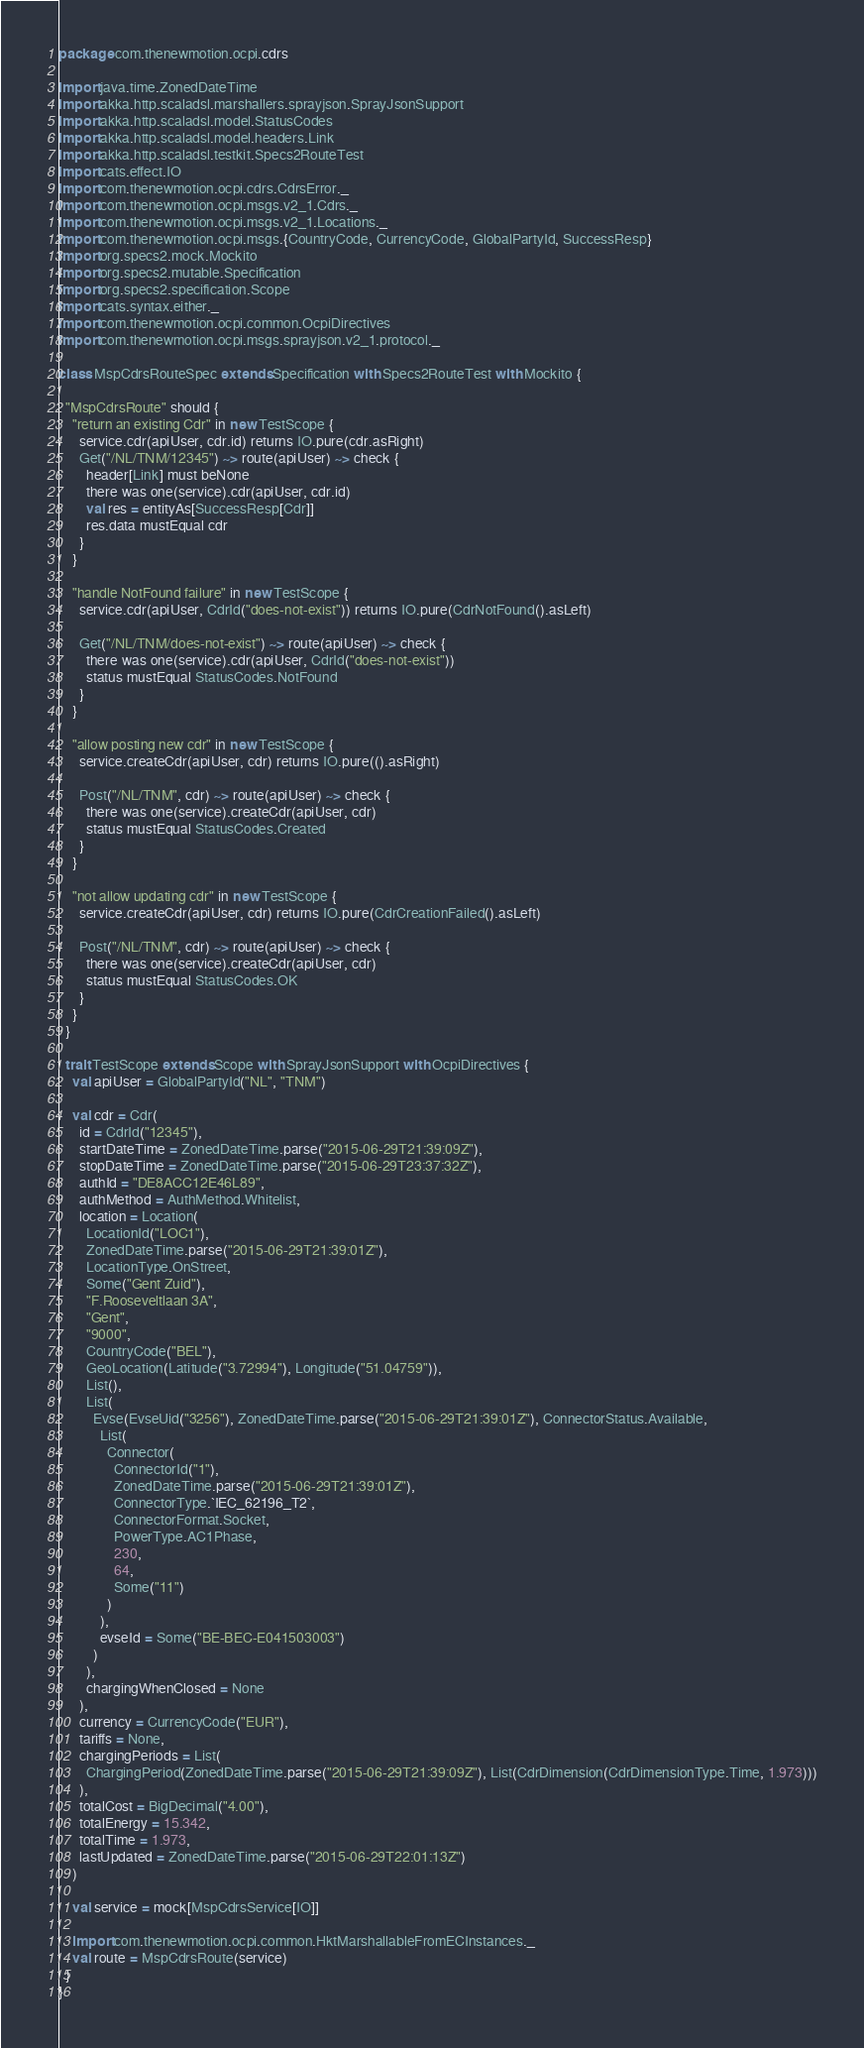<code> <loc_0><loc_0><loc_500><loc_500><_Scala_>package com.thenewmotion.ocpi.cdrs

import java.time.ZonedDateTime
import akka.http.scaladsl.marshallers.sprayjson.SprayJsonSupport
import akka.http.scaladsl.model.StatusCodes
import akka.http.scaladsl.model.headers.Link
import akka.http.scaladsl.testkit.Specs2RouteTest
import cats.effect.IO
import com.thenewmotion.ocpi.cdrs.CdrsError._
import com.thenewmotion.ocpi.msgs.v2_1.Cdrs._
import com.thenewmotion.ocpi.msgs.v2_1.Locations._
import com.thenewmotion.ocpi.msgs.{CountryCode, CurrencyCode, GlobalPartyId, SuccessResp}
import org.specs2.mock.Mockito
import org.specs2.mutable.Specification
import org.specs2.specification.Scope
import cats.syntax.either._
import com.thenewmotion.ocpi.common.OcpiDirectives
import com.thenewmotion.ocpi.msgs.sprayjson.v2_1.protocol._

class MspCdrsRouteSpec extends Specification with Specs2RouteTest with Mockito {

  "MspCdrsRoute" should {
    "return an existing Cdr" in new TestScope {
      service.cdr(apiUser, cdr.id) returns IO.pure(cdr.asRight)
      Get("/NL/TNM/12345") ~> route(apiUser) ~> check {
        header[Link] must beNone
        there was one(service).cdr(apiUser, cdr.id)
        val res = entityAs[SuccessResp[Cdr]]
        res.data mustEqual cdr
      }
    }

    "handle NotFound failure" in new TestScope {
      service.cdr(apiUser, CdrId("does-not-exist")) returns IO.pure(CdrNotFound().asLeft)

      Get("/NL/TNM/does-not-exist") ~> route(apiUser) ~> check {
        there was one(service).cdr(apiUser, CdrId("does-not-exist"))
        status mustEqual StatusCodes.NotFound
      }
    }

    "allow posting new cdr" in new TestScope {
      service.createCdr(apiUser, cdr) returns IO.pure(().asRight)

      Post("/NL/TNM", cdr) ~> route(apiUser) ~> check {
        there was one(service).createCdr(apiUser, cdr)
        status mustEqual StatusCodes.Created
      }
    }

    "not allow updating cdr" in new TestScope {
      service.createCdr(apiUser, cdr) returns IO.pure(CdrCreationFailed().asLeft)

      Post("/NL/TNM", cdr) ~> route(apiUser) ~> check {
        there was one(service).createCdr(apiUser, cdr)
        status mustEqual StatusCodes.OK
      }
    }
  }

  trait TestScope extends Scope with SprayJsonSupport with OcpiDirectives {
    val apiUser = GlobalPartyId("NL", "TNM")

    val cdr = Cdr(
      id = CdrId("12345"),
      startDateTime = ZonedDateTime.parse("2015-06-29T21:39:09Z"),
      stopDateTime = ZonedDateTime.parse("2015-06-29T23:37:32Z"),
      authId = "DE8ACC12E46L89",
      authMethod = AuthMethod.Whitelist,
      location = Location(
        LocationId("LOC1"),
        ZonedDateTime.parse("2015-06-29T21:39:01Z"),
        LocationType.OnStreet,
        Some("Gent Zuid"),
        "F.Rooseveltlaan 3A",
        "Gent",
        "9000",
        CountryCode("BEL"),
        GeoLocation(Latitude("3.72994"), Longitude("51.04759")),
        List(),
        List(
          Evse(EvseUid("3256"), ZonedDateTime.parse("2015-06-29T21:39:01Z"), ConnectorStatus.Available,
            List(
              Connector(
                ConnectorId("1"),
                ZonedDateTime.parse("2015-06-29T21:39:01Z"),
                ConnectorType.`IEC_62196_T2`,
                ConnectorFormat.Socket,
                PowerType.AC1Phase,
                230,
                64,
                Some("11")
              )
            ),
            evseId = Some("BE-BEC-E041503003")
          )
        ),
        chargingWhenClosed = None
      ),
      currency = CurrencyCode("EUR"),
      tariffs = None,
      chargingPeriods = List(
        ChargingPeriod(ZonedDateTime.parse("2015-06-29T21:39:09Z"), List(CdrDimension(CdrDimensionType.Time, 1.973)))
      ),
      totalCost = BigDecimal("4.00"),
      totalEnergy = 15.342,
      totalTime = 1.973,
      lastUpdated = ZonedDateTime.parse("2015-06-29T22:01:13Z")
    )

    val service = mock[MspCdrsService[IO]]

    import com.thenewmotion.ocpi.common.HktMarshallableFromECInstances._
    val route = MspCdrsRoute(service)
  }
}
</code> 